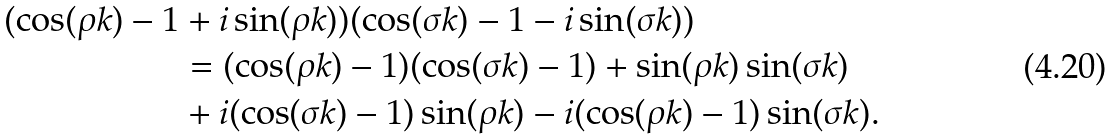<formula> <loc_0><loc_0><loc_500><loc_500>( \cos ( \rho k ) - 1 & + i \sin ( \rho k ) ) ( \cos ( \sigma k ) - 1 - i \sin ( \sigma k ) ) \\ & = ( \cos ( \rho k ) - 1 ) ( \cos ( \sigma k ) - 1 ) + \sin ( \rho k ) \sin ( \sigma k ) \\ & + i ( \cos ( \sigma k ) - 1 ) \sin ( \rho k ) - i ( \cos ( \rho k ) - 1 ) \sin ( \sigma k ) .</formula> 